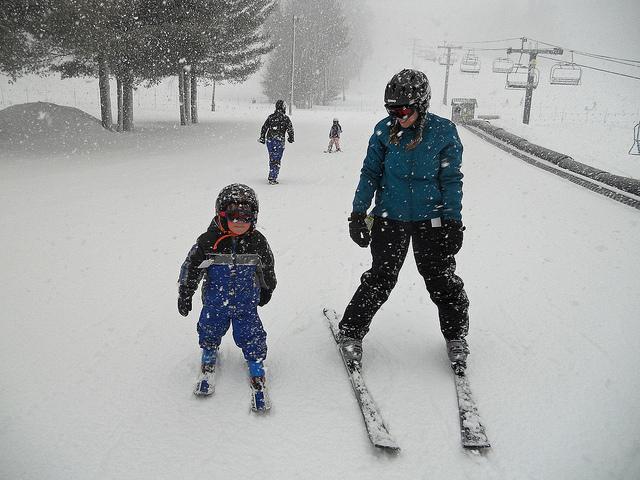Is it snowing?
Answer briefly. Yes. What is on the right of the picture?
Give a very brief answer. Ski lift. How many kids are in this picture?
Concise answer only. 2. Is it difficult for the viewer to see the tree in the center background?
Concise answer only. Yes. What color are the child's boots?
Keep it brief. Blue. What the people holding?
Concise answer only. Nothing. How many skiers are in this picture?
Short answer required. 4. What color of cloth is the girl wearing?
Be succinct. Blue and black. 